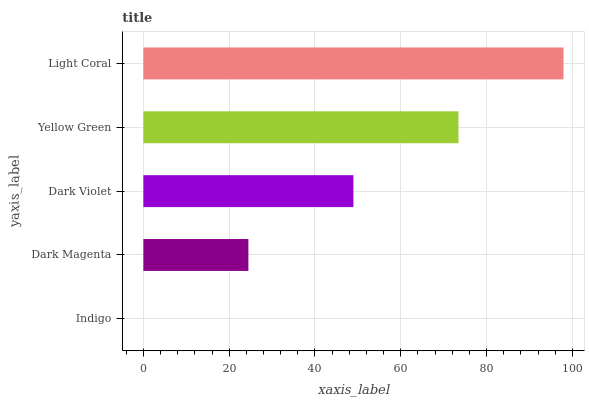Is Indigo the minimum?
Answer yes or no. Yes. Is Light Coral the maximum?
Answer yes or no. Yes. Is Dark Magenta the minimum?
Answer yes or no. No. Is Dark Magenta the maximum?
Answer yes or no. No. Is Dark Magenta greater than Indigo?
Answer yes or no. Yes. Is Indigo less than Dark Magenta?
Answer yes or no. Yes. Is Indigo greater than Dark Magenta?
Answer yes or no. No. Is Dark Magenta less than Indigo?
Answer yes or no. No. Is Dark Violet the high median?
Answer yes or no. Yes. Is Dark Violet the low median?
Answer yes or no. Yes. Is Yellow Green the high median?
Answer yes or no. No. Is Yellow Green the low median?
Answer yes or no. No. 